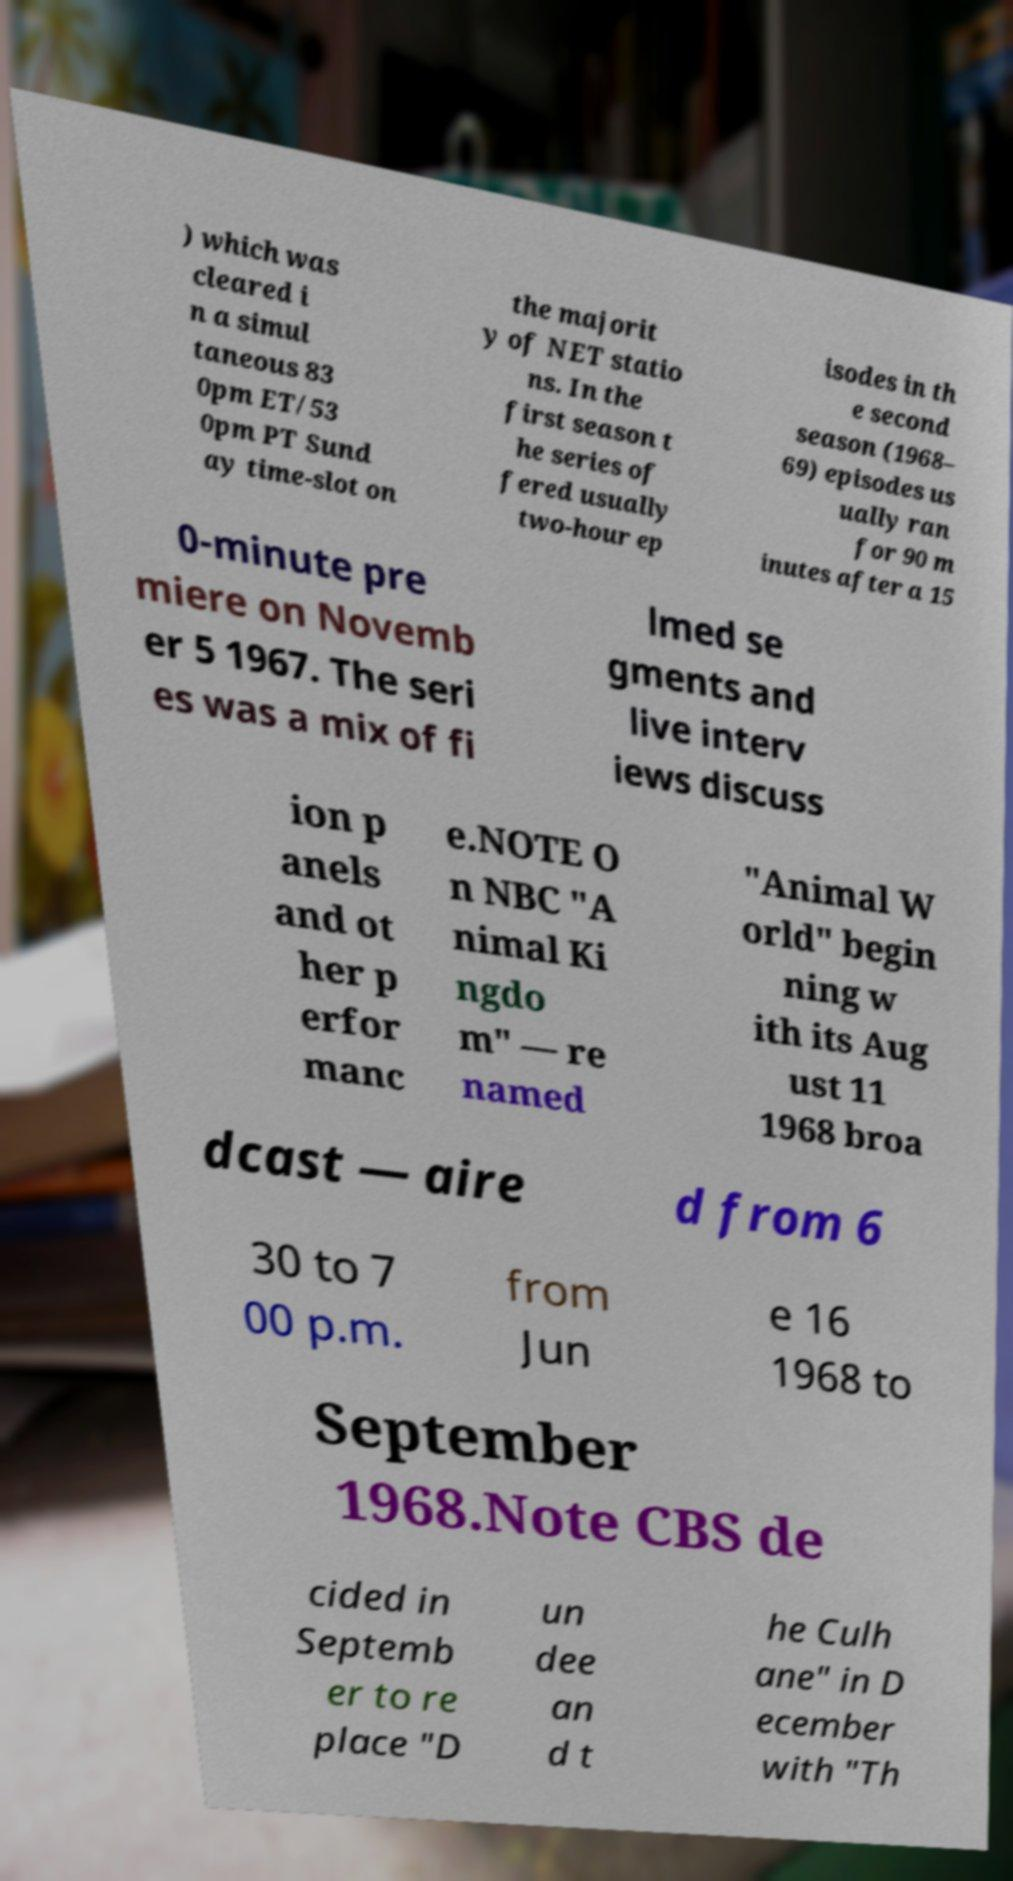Could you extract and type out the text from this image? ) which was cleared i n a simul taneous 83 0pm ET/53 0pm PT Sund ay time-slot on the majorit y of NET statio ns. In the first season t he series of fered usually two-hour ep isodes in th e second season (1968– 69) episodes us ually ran for 90 m inutes after a 15 0-minute pre miere on Novemb er 5 1967. The seri es was a mix of fi lmed se gments and live interv iews discuss ion p anels and ot her p erfor manc e.NOTE O n NBC "A nimal Ki ngdo m" — re named "Animal W orld" begin ning w ith its Aug ust 11 1968 broa dcast — aire d from 6 30 to 7 00 p.m. from Jun e 16 1968 to September 1968.Note CBS de cided in Septemb er to re place "D un dee an d t he Culh ane" in D ecember with "Th 